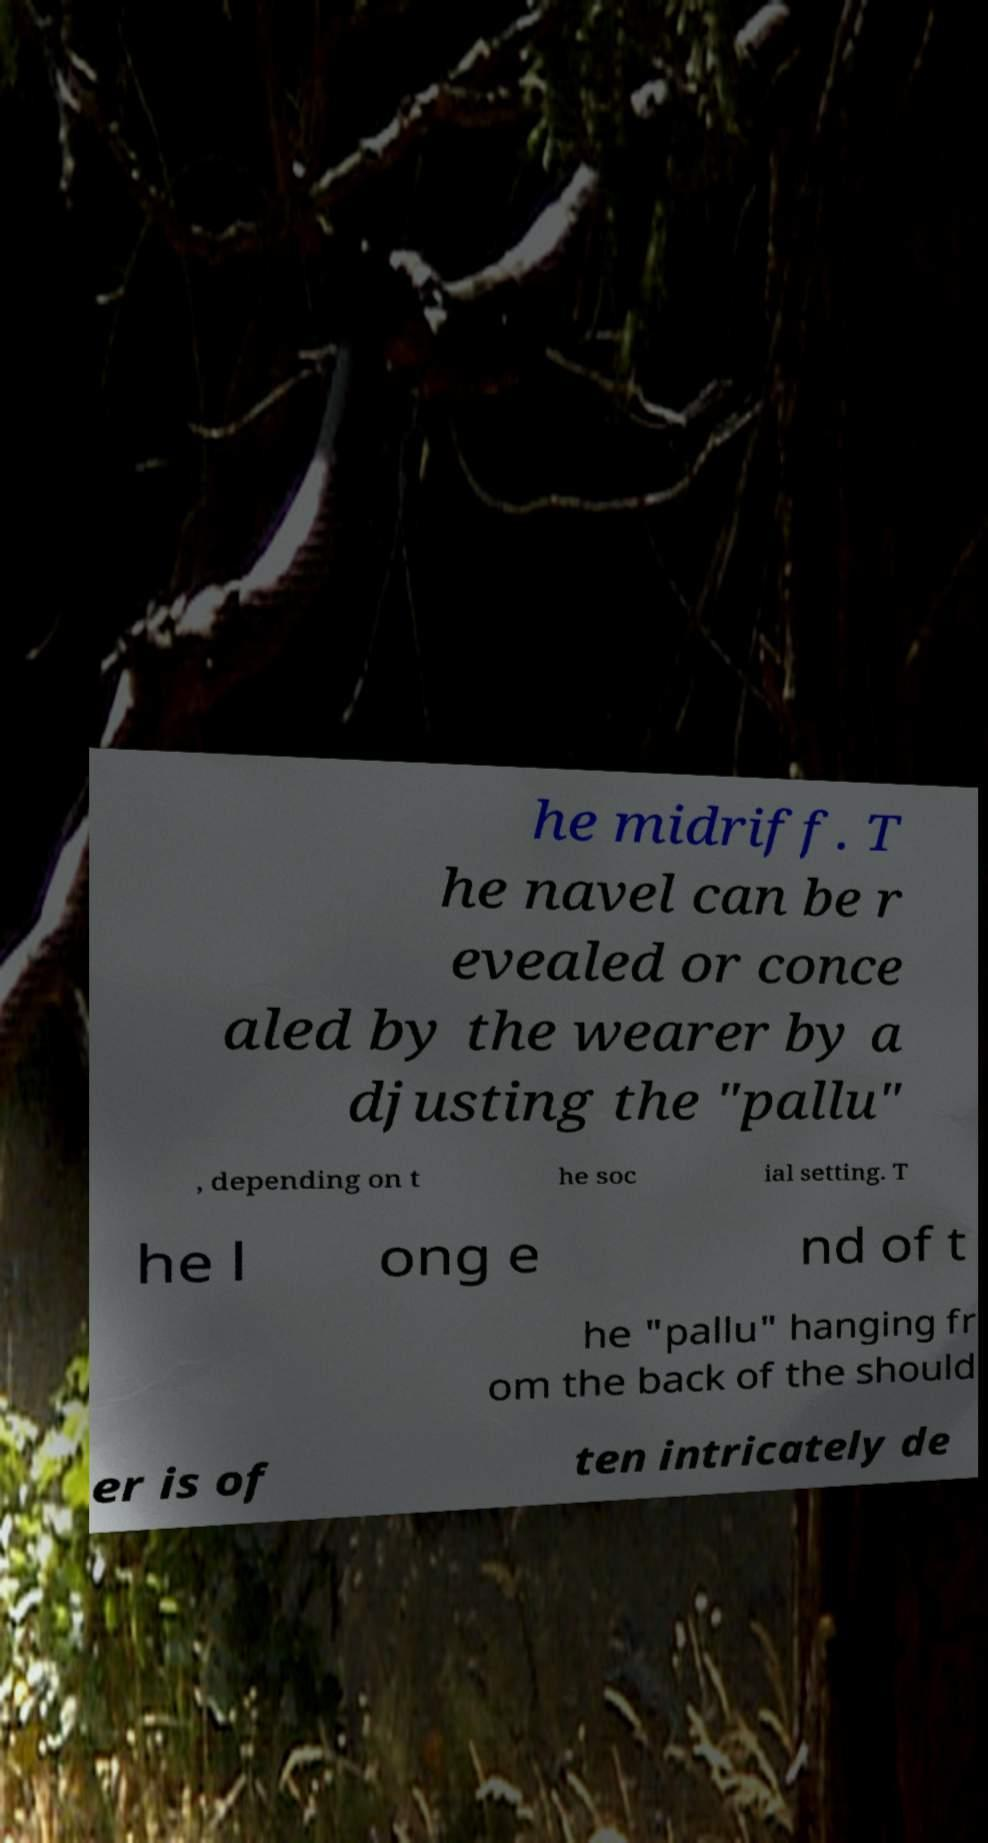Can you accurately transcribe the text from the provided image for me? he midriff. T he navel can be r evealed or conce aled by the wearer by a djusting the "pallu" , depending on t he soc ial setting. T he l ong e nd of t he "pallu" hanging fr om the back of the should er is of ten intricately de 